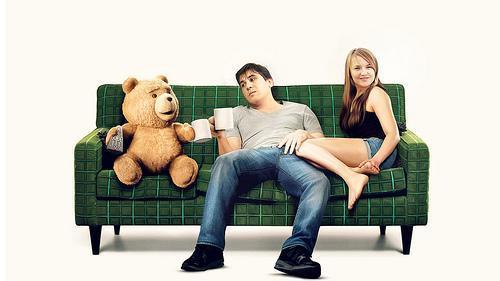How many coffee mugs are there?
Give a very brief answer. 2. How many humans are there?
Give a very brief answer. 2. 